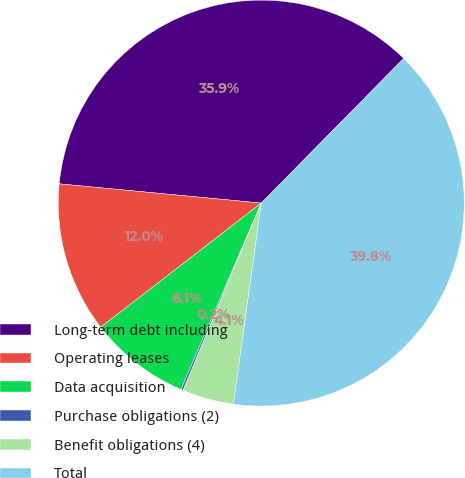Convert chart. <chart><loc_0><loc_0><loc_500><loc_500><pie_chart><fcel>Long-term debt including<fcel>Operating leases<fcel>Data acquisition<fcel>Purchase obligations (2)<fcel>Benefit obligations (4)<fcel>Total<nl><fcel>35.87%<fcel>11.99%<fcel>8.05%<fcel>0.17%<fcel>4.11%<fcel>39.81%<nl></chart> 